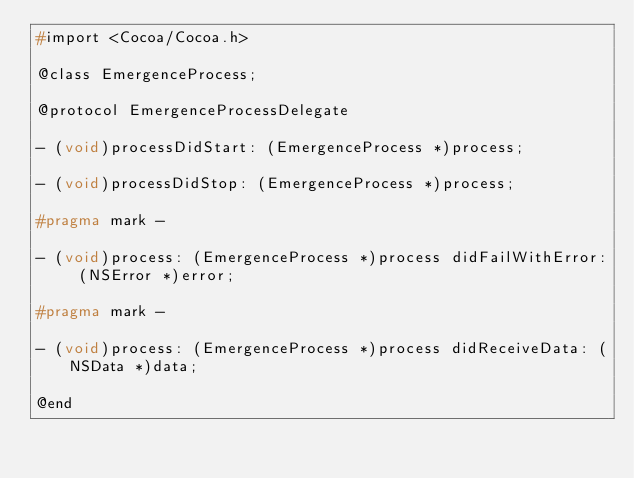Convert code to text. <code><loc_0><loc_0><loc_500><loc_500><_C_>#import <Cocoa/Cocoa.h>

@class EmergenceProcess;

@protocol EmergenceProcessDelegate

- (void)processDidStart: (EmergenceProcess *)process;

- (void)processDidStop: (EmergenceProcess *)process;

#pragma mark -

- (void)process: (EmergenceProcess *)process didFailWithError: (NSError *)error;

#pragma mark -

- (void)process: (EmergenceProcess *)process didReceiveData: (NSData *)data;

@end
</code> 